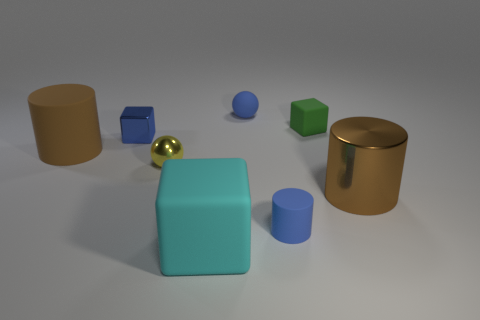Add 2 blue rubber spheres. How many objects exist? 10 Subtract all blocks. How many objects are left? 5 Subtract all large metallic objects. Subtract all small gray rubber balls. How many objects are left? 7 Add 4 brown metal cylinders. How many brown metal cylinders are left? 5 Add 1 large purple objects. How many large purple objects exist? 1 Subtract 1 cyan cubes. How many objects are left? 7 